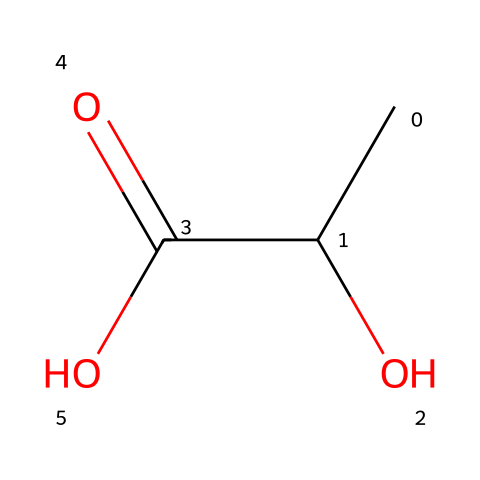What is the name of this monomer? This chemical structure represents lactic acid, which is the monomeric unit of polylactic acid (PLA). The presence of the hydroxyl group (-OH) and the carboxylic acid group (-COOH) confirms that it's lactic acid.
Answer: lactic acid How many carbon atoms are present in the chemical? The SMILES notation CC(O)C(=O)O shows there are three carbon atoms. Counting the 'C' in the notation reveals the number of carbon atoms.
Answer: 3 What type of functional groups are present in this structure? This chemical contains two functional groups: a hydroxyl group (-OH) and a carboxylic acid group (-COOH). The structure shows these groups explicitly connected to the carbon atoms.
Answer: hydroxyl and carboxylic acid What is the degree of saturation of this chemical? The degree of saturation can be derived from the number of double bonds and rings. In this case, this structure is fully saturated (no double bonds that would introduce rings or unsaturation), indicating it has a degree of saturation of 0.
Answer: 0 What is the molecular formula of this monomer? By analyzing the structure, we find that there are three carbon atoms (C), six hydrogen atoms (H), and three oxygen atoms (O). Therefore, the molecular formula derived from the element count is C3H6O3.
Answer: C3H6O3 Does this monomer form part of a biodegradable polymer? Yes, lactic acid is known to polymerize to form polylactic acid (PLA), which is a common biodegradable plastic utilized in eco-friendly applications.
Answer: Yes 